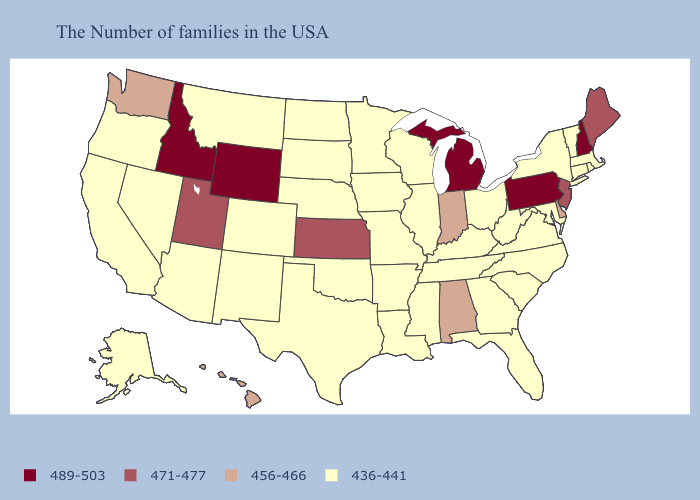Name the states that have a value in the range 489-503?
Be succinct. New Hampshire, Pennsylvania, Michigan, Wyoming, Idaho. What is the lowest value in the USA?
Concise answer only. 436-441. Does West Virginia have the lowest value in the USA?
Concise answer only. Yes. Which states have the lowest value in the USA?
Write a very short answer. Massachusetts, Rhode Island, Vermont, Connecticut, New York, Maryland, Virginia, North Carolina, South Carolina, West Virginia, Ohio, Florida, Georgia, Kentucky, Tennessee, Wisconsin, Illinois, Mississippi, Louisiana, Missouri, Arkansas, Minnesota, Iowa, Nebraska, Oklahoma, Texas, South Dakota, North Dakota, Colorado, New Mexico, Montana, Arizona, Nevada, California, Oregon, Alaska. What is the value of Georgia?
Answer briefly. 436-441. What is the lowest value in the Northeast?
Quick response, please. 436-441. What is the highest value in states that border Arkansas?
Write a very short answer. 436-441. What is the value of Louisiana?
Keep it brief. 436-441. Does Wyoming have the highest value in the USA?
Give a very brief answer. Yes. What is the lowest value in the USA?
Answer briefly. 436-441. Name the states that have a value in the range 471-477?
Concise answer only. Maine, New Jersey, Kansas, Utah. What is the lowest value in the Northeast?
Write a very short answer. 436-441. Name the states that have a value in the range 436-441?
Be succinct. Massachusetts, Rhode Island, Vermont, Connecticut, New York, Maryland, Virginia, North Carolina, South Carolina, West Virginia, Ohio, Florida, Georgia, Kentucky, Tennessee, Wisconsin, Illinois, Mississippi, Louisiana, Missouri, Arkansas, Minnesota, Iowa, Nebraska, Oklahoma, Texas, South Dakota, North Dakota, Colorado, New Mexico, Montana, Arizona, Nevada, California, Oregon, Alaska. What is the value of Wyoming?
Answer briefly. 489-503. 